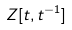Convert formula to latex. <formula><loc_0><loc_0><loc_500><loc_500>Z [ t , t ^ { - 1 } ]</formula> 